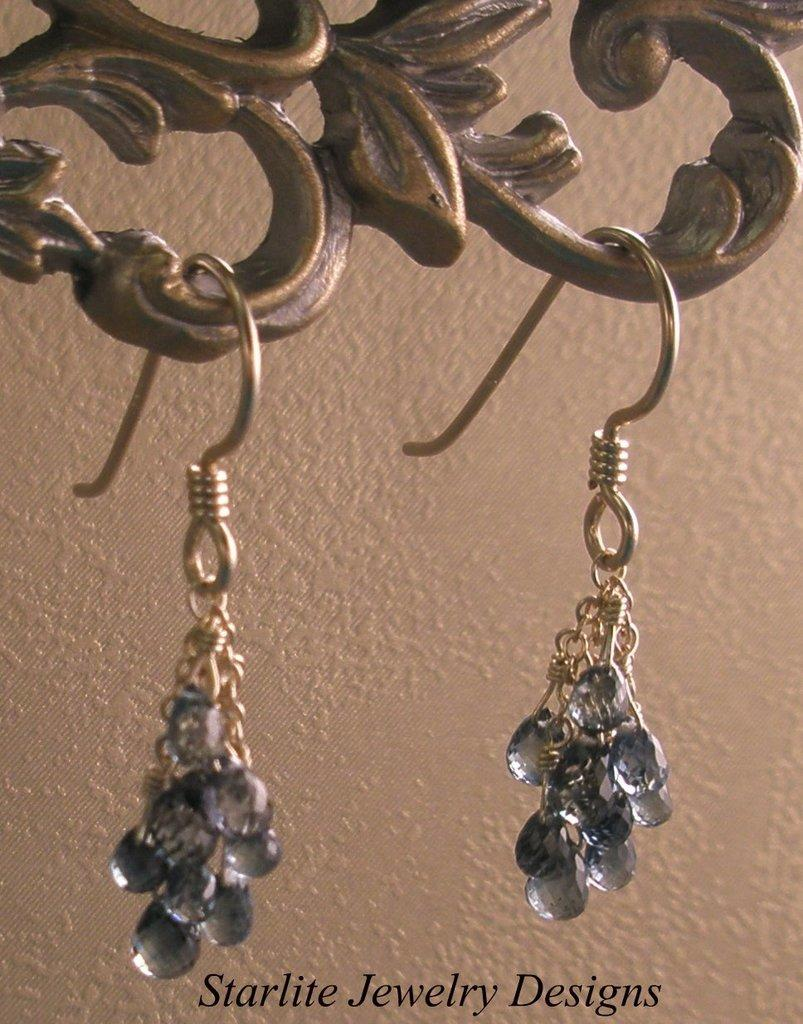What type of jewelry is featured in the image? There are two earrings in the image. How are the earrings displayed in the image? The earrings are hanging from a metal object. What can be seen in the background of the image? There is a wall in the background of the image. Is there any text present in the image? Yes, there is edited text at the bottom of the image. How many lizards are crawling on the wall in the image? There are no lizards present in the image; it only features earrings and edited text. What type of ring is shown on the metal object in the image? There is no ring present in the image; it only features earrings. 